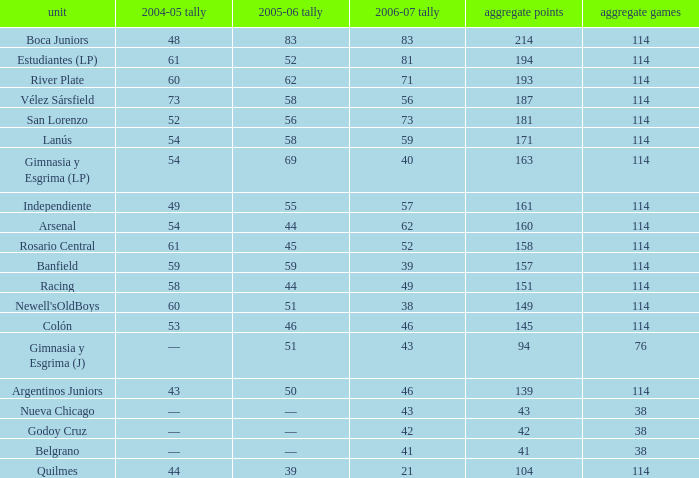What is the overall sum of points for a total pld below 38? 0.0. 